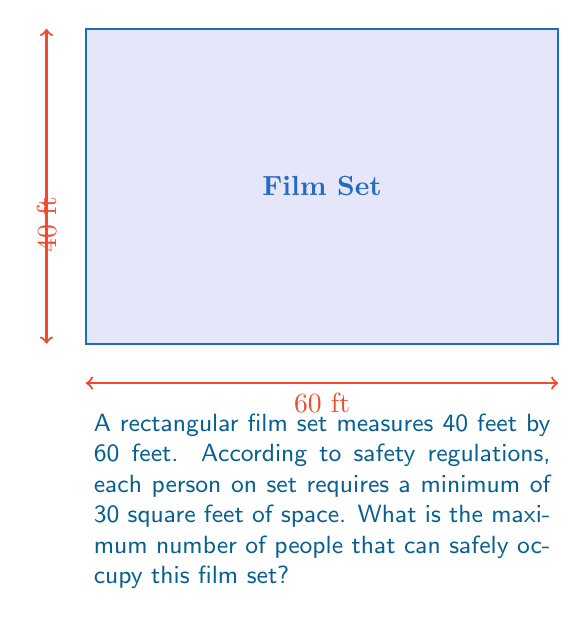Teach me how to tackle this problem. To solve this problem, we'll follow these steps:

1. Calculate the total area of the film set:
   $$\text{Area} = \text{Length} \times \text{Width}$$
   $$\text{Area} = 60 \text{ ft} \times 40 \text{ ft} = 2400 \text{ sq ft}$$

2. Determine the space required per person:
   Each person needs 30 square feet of space.

3. Calculate the maximum number of people:
   $$\text{Max People} = \frac{\text{Total Area}}{\text{Area per Person}}$$
   $$\text{Max People} = \frac{2400 \text{ sq ft}}{30 \text{ sq ft/person}}$$
   $$\text{Max People} = 80$$

4. Since we can't have a fraction of a person, we round down to the nearest whole number.

Therefore, the maximum number of people that can safely occupy this film set is 80.
Answer: 80 people 